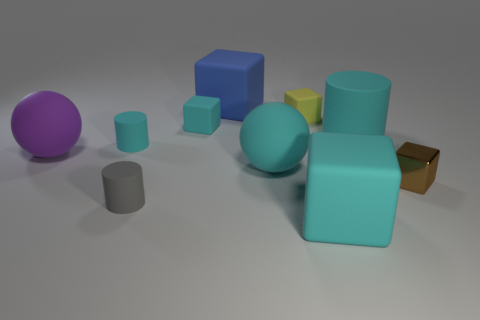What is the size of the other sphere that is made of the same material as the purple ball?
Offer a terse response. Large. What size is the purple matte sphere?
Keep it short and to the point. Large. Do the small yellow object and the large cyan cylinder have the same material?
Provide a succinct answer. Yes. How many spheres are either large purple objects or large gray rubber objects?
Give a very brief answer. 1. There is a big ball that is on the right side of the small thing that is in front of the small brown shiny object; what is its color?
Give a very brief answer. Cyan. What is the size of the other cylinder that is the same color as the large cylinder?
Provide a short and direct response. Small. There is a cyan cylinder to the left of the large thing in front of the big cyan sphere; what number of small cubes are in front of it?
Your response must be concise. 1. Do the purple thing behind the big cyan matte ball and the small rubber object that is to the right of the blue rubber object have the same shape?
Your answer should be very brief. No. How many objects are cyan cylinders or small yellow cubes?
Keep it short and to the point. 3. There is a cyan block in front of the cyan cube that is behind the tiny brown cube; what is its material?
Make the answer very short. Rubber. 